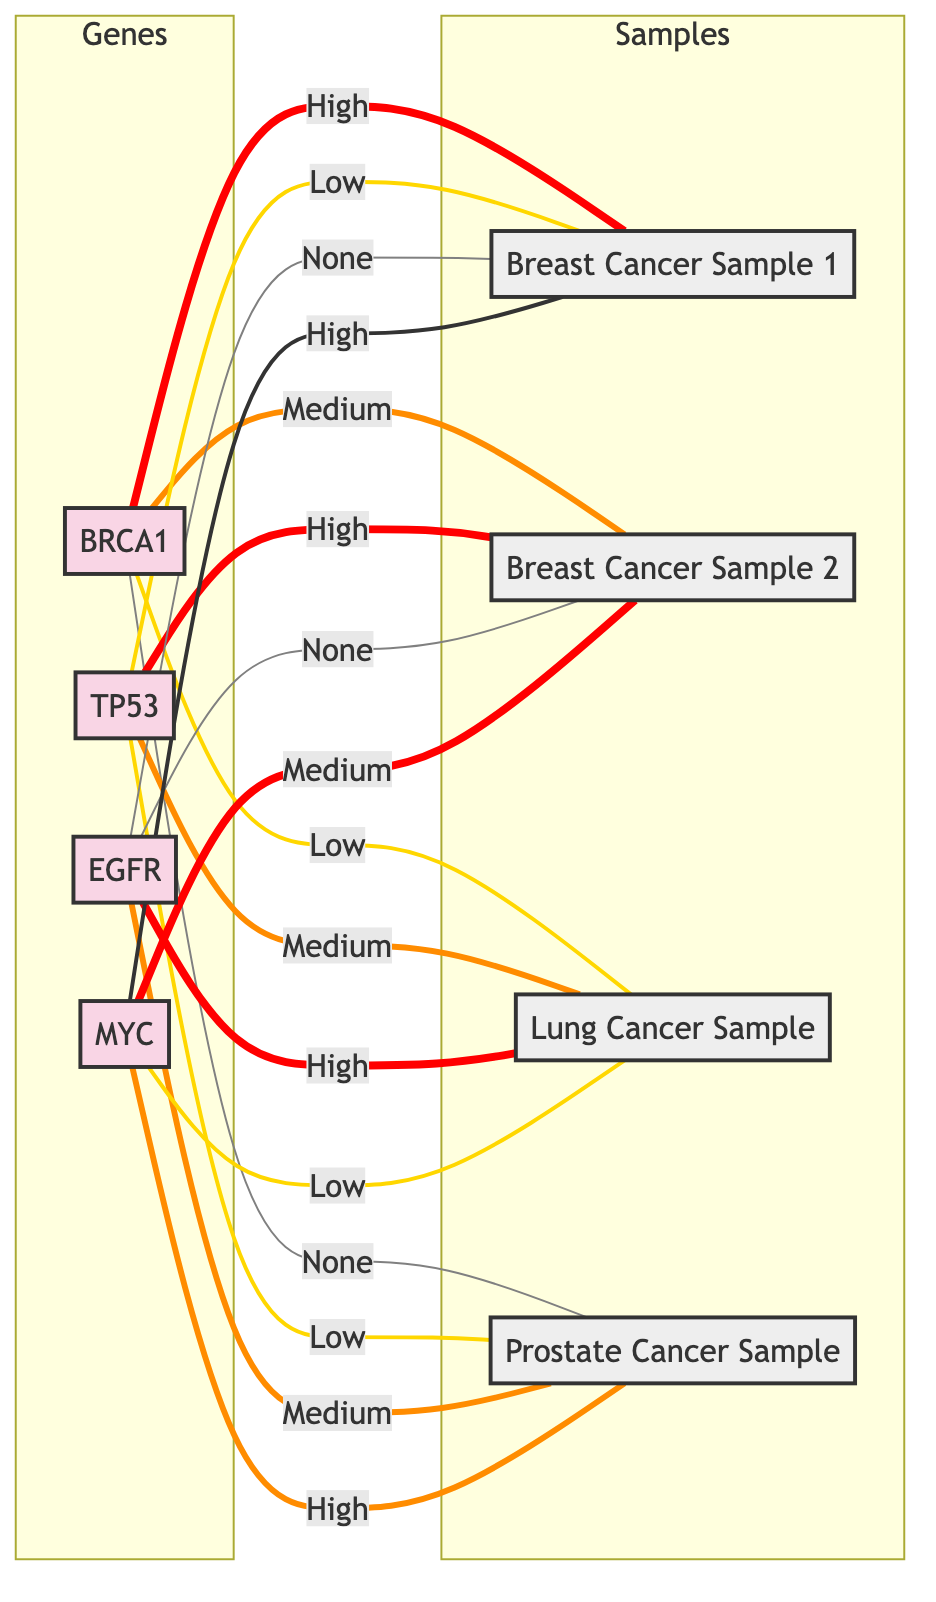What is the expression level of BRCA1 in Breast Cancer Sample 1? The diagram shows that BRCA1 has a "High" expression level when connected to Breast Cancer Sample 1.
Answer: High Which gene has the highest expression in Lung Cancer Sample? According to the diagram, EGFR has a "High" expression level in Lung Cancer Sample, which is higher than the others.
Answer: EGFR How many genes have "None" expression in Prostate Cancer Sample? In the diagram, out of four genes, two genes (BRCA1 and TP53) show "None" expression in Prostate Cancer Sample.
Answer: 2 What is the expression level of TP53 in Breast Cancer Sample 2? The diagram indicates that TP53 has a "High" expression level in Breast Cancer Sample 2 depicted by its connection.
Answer: High In which sample does MYC have a "Low" expression? Analyzing the diagram, MYC is connected with a "Low" expression to Lung Cancer Sample.
Answer: Lung Cancer Sample Which gene has the lowest expression in Breast Cancer Sample 1? The diagram reveals that TP53 is shown to have a "Low" expression in Breast Cancer Sample 1, the lowest among the genes.
Answer: TP53 Which sample has no expression for EGFR? The diagram shows that both Breast Cancer Sample 1 and Breast Cancer Sample 2 are connected with "None" expression to EGFR.
Answer: Breast Cancer Sample 1 and Breast Cancer Sample 2 What is the expression of MYC in Lung Cancer Sample? The diagram specifies that MYC is marked with "Low" expression in Lung Cancer Sample, indicating less activity of this gene.
Answer: Low How is the expression pattern of BRCA1 compared to TP53 in all samples? By analyzing the connections in the diagram, BRCA1's levels fluctuate (High in Breast Cancer Sample 1, Medium in Sample 2, Low in Lung Cancer Sample, and None in Prostate Cancer), while TP53 has a consistent Low with variations; hence BRCA1 shows a more dynamic expression pattern compared to the consistent lower levels of TP53.
Answer: BRCA1 is more dynamic than TP53 